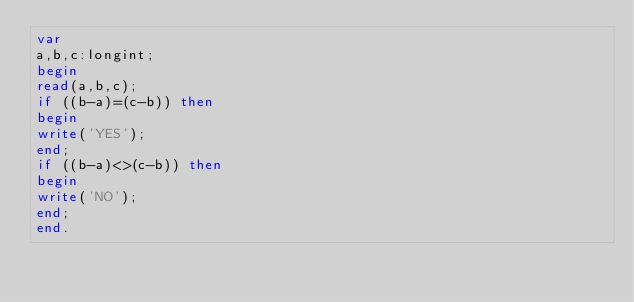<code> <loc_0><loc_0><loc_500><loc_500><_Pascal_>var
a,b,c:longint;
begin
read(a,b,c);
if ((b-a)=(c-b)) then
begin
write('YES');
end;
if ((b-a)<>(c-b)) then
begin
write('NO');
end;
end.</code> 